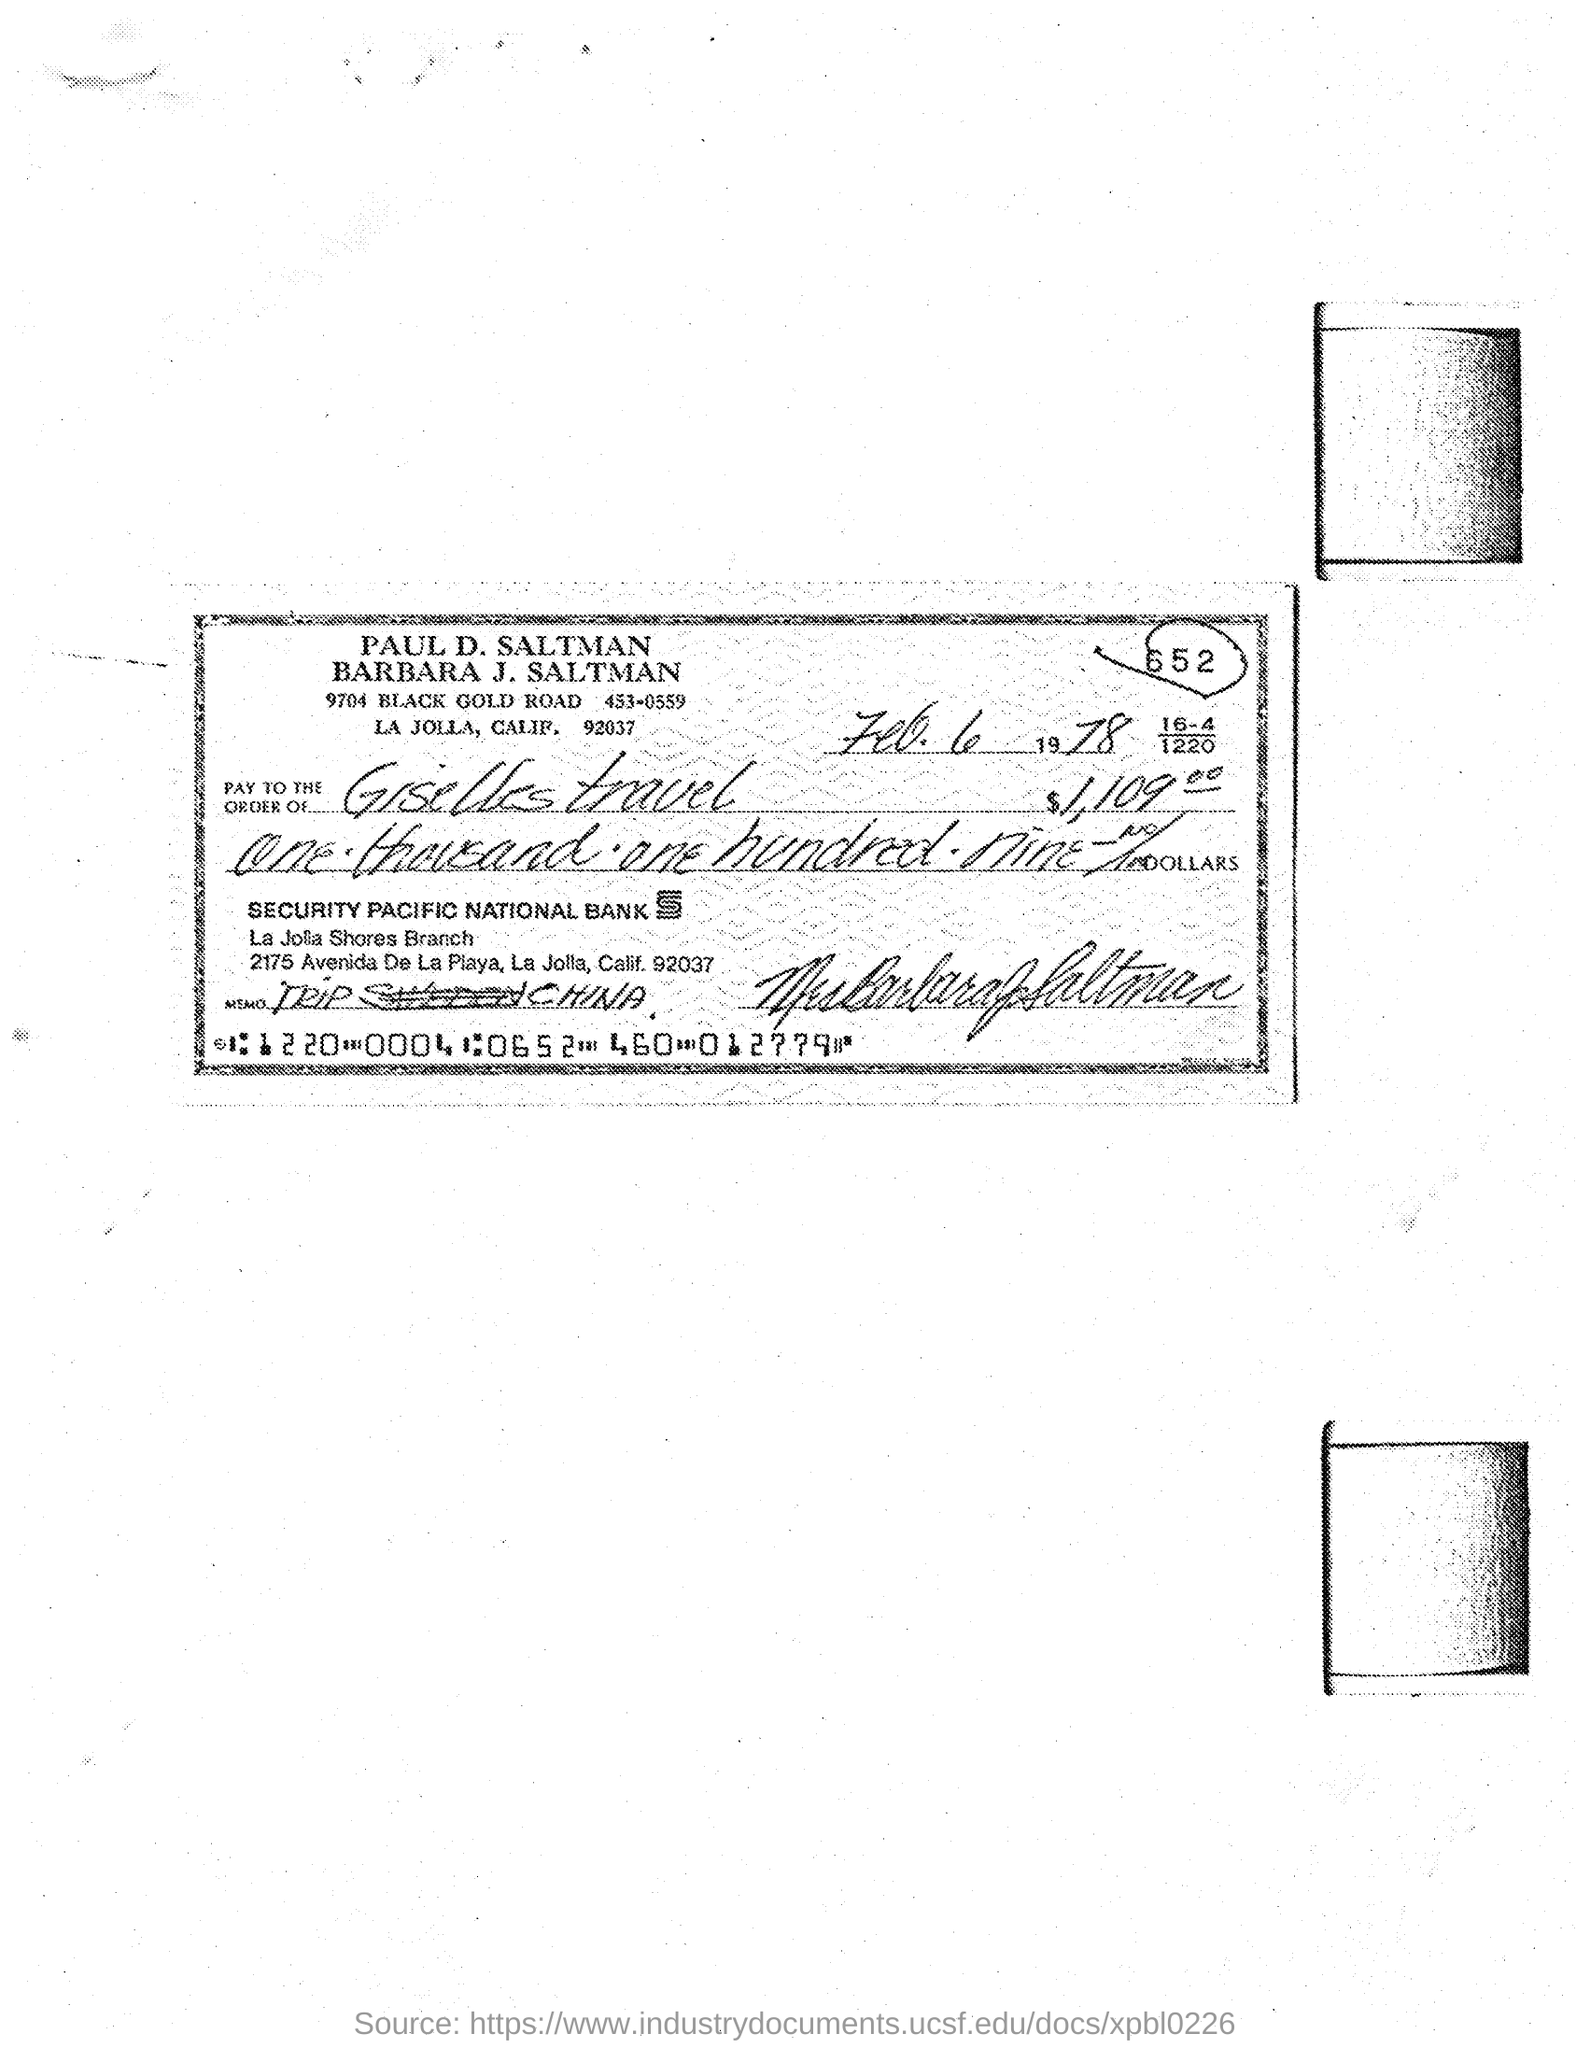What is the date of the cheque?
Offer a terse response. Feb. 6 1978. 